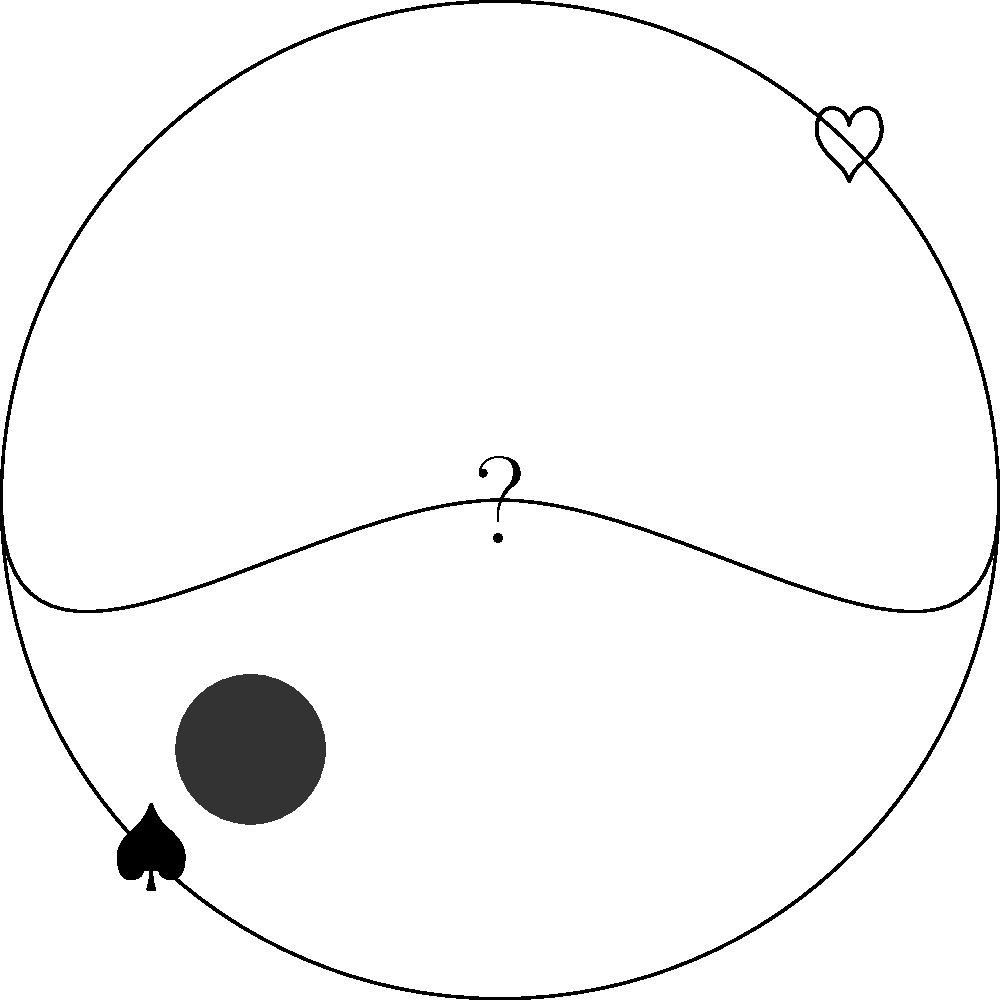In this visual representation of ethical relativism, what does the central question mark symbolize, and how does it relate to Frédéric Lenoir's perspective on cultural diversity and ethics? To analyze this visual puzzle and answer the question, let's break it down step-by-step:

1. The image shows a Yin-Yang symbol within a circle, representing the world or global perspective.

2. The Yin-Yang symbol itself represents balance, duality, and interconnectedness in Chinese philosophy.

3. The heart and spade symbols on opposite sides represent contrasting cultural values or ethical systems.

4. The central question mark indicates uncertainty or questioning, which is key to ethical relativism.

5. Ethical relativism is the view that moral truths are relative to the cultural or individual perspective, not absolute.

6. Frédéric Lenoir, as a philosopher, emphasizes the importance of cultural diversity and dialogue in ethical considerations.

7. The question mark in this context symbolizes the critical inquiry and open-mindedness necessary when confronting different ethical systems.

8. It also represents the challenge of finding universal ethical principles amidst diverse cultural values, a theme Lenoir often explores.

9. The balance of the Yin-Yang suggests that different ethical systems can coexist and complement each other, aligning with Lenoir's inclusive approach.

10. The overall image encourages viewers to question absolute ethical truths and consider the validity of different cultural perspectives, a key aspect of Lenoir's philosophical stance.
Answer: The central question mark symbolizes critical inquiry and ethical uncertainty in a diverse world, reflecting Lenoir's emphasis on cultural dialogue and moral reflection. 